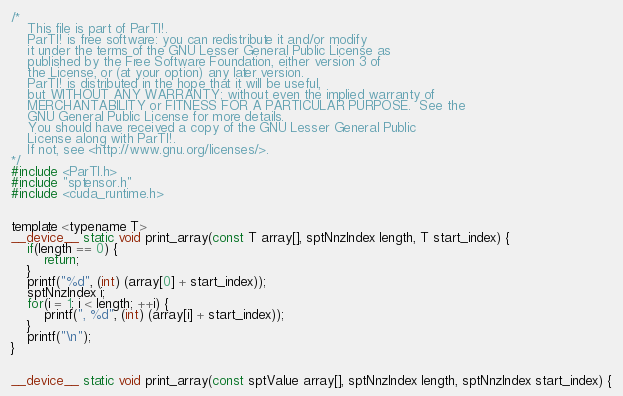<code> <loc_0><loc_0><loc_500><loc_500><_Cuda_>/*
    This file is part of ParTI!.
    ParTI! is free software: you can redistribute it and/or modify
    it under the terms of the GNU Lesser General Public License as
    published by the Free Software Foundation, either version 3 of
    the License, or (at your option) any later version.
    ParTI! is distributed in the hope that it will be useful,
    but WITHOUT ANY WARRANTY; without even the implied warranty of
    MERCHANTABILITY or FITNESS FOR A PARTICULAR PURPOSE.  See the
    GNU General Public License for more details.
    You should have received a copy of the GNU Lesser General Public
    License along with ParTI!.
    If not, see <http://www.gnu.org/licenses/>.
*/
#include <ParTI.h>
#include "sptensor.h"
#include <cuda_runtime.h>


template <typename T>
__device__ static void print_array(const T array[], sptNnzIndex length, T start_index) {
    if(length == 0) {
        return;
    }
    printf("%d", (int) (array[0] + start_index));
    sptNnzIndex i;
    for(i = 1; i < length; ++i) {
        printf(", %d", (int) (array[i] + start_index));
    }
    printf("\n");
}


__device__ static void print_array(const sptValue array[], sptNnzIndex length, sptNnzIndex start_index) {</code> 